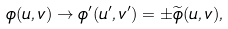<formula> <loc_0><loc_0><loc_500><loc_500>\phi ( u , v ) \rightarrow \phi ^ { \prime } ( u ^ { \prime } , v ^ { \prime } ) = \pm \widetilde { \phi } ( u , v ) ,</formula> 